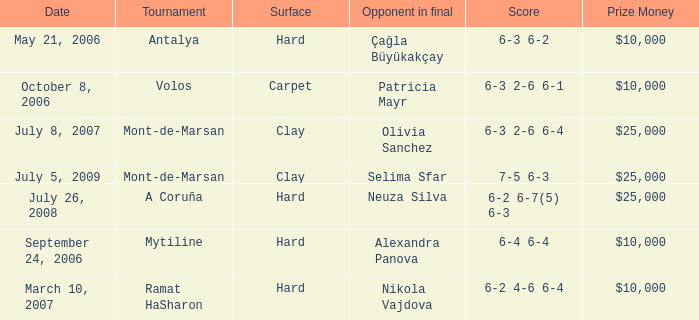What is the surface of the match on July 5, 2009? Clay. 